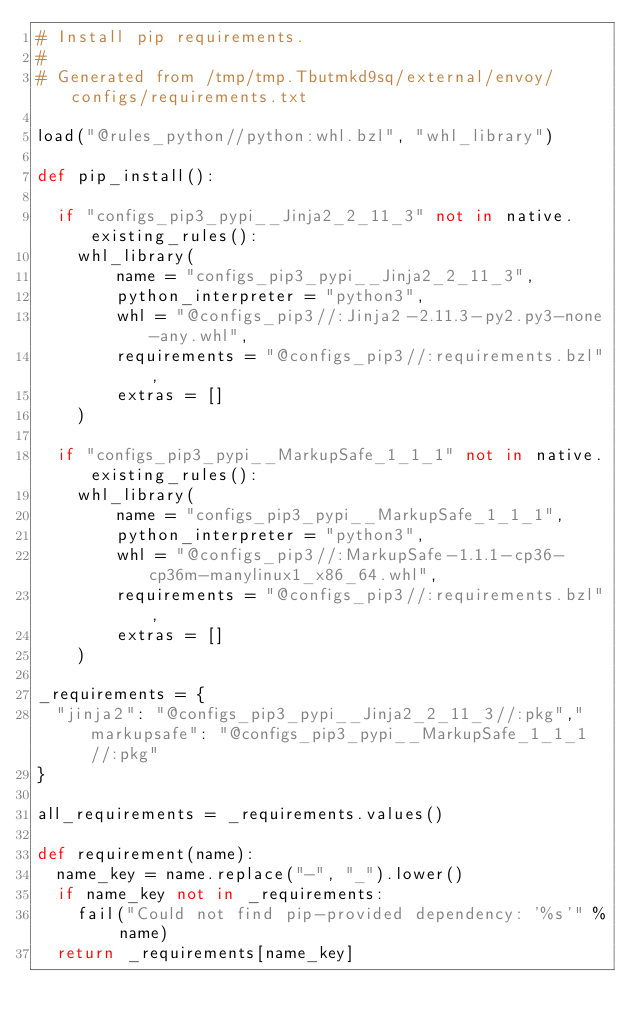<code> <loc_0><loc_0><loc_500><loc_500><_Python_># Install pip requirements.
#
# Generated from /tmp/tmp.Tbutmkd9sq/external/envoy/configs/requirements.txt

load("@rules_python//python:whl.bzl", "whl_library")

def pip_install():
  
  if "configs_pip3_pypi__Jinja2_2_11_3" not in native.existing_rules():
    whl_library(
        name = "configs_pip3_pypi__Jinja2_2_11_3",
        python_interpreter = "python3",
        whl = "@configs_pip3//:Jinja2-2.11.3-py2.py3-none-any.whl",
        requirements = "@configs_pip3//:requirements.bzl",
        extras = []
    )

  if "configs_pip3_pypi__MarkupSafe_1_1_1" not in native.existing_rules():
    whl_library(
        name = "configs_pip3_pypi__MarkupSafe_1_1_1",
        python_interpreter = "python3",
        whl = "@configs_pip3//:MarkupSafe-1.1.1-cp36-cp36m-manylinux1_x86_64.whl",
        requirements = "@configs_pip3//:requirements.bzl",
        extras = []
    )

_requirements = {
  "jinja2": "@configs_pip3_pypi__Jinja2_2_11_3//:pkg","markupsafe": "@configs_pip3_pypi__MarkupSafe_1_1_1//:pkg"
}

all_requirements = _requirements.values()

def requirement(name):
  name_key = name.replace("-", "_").lower()
  if name_key not in _requirements:
    fail("Could not find pip-provided dependency: '%s'" % name)
  return _requirements[name_key]
</code> 